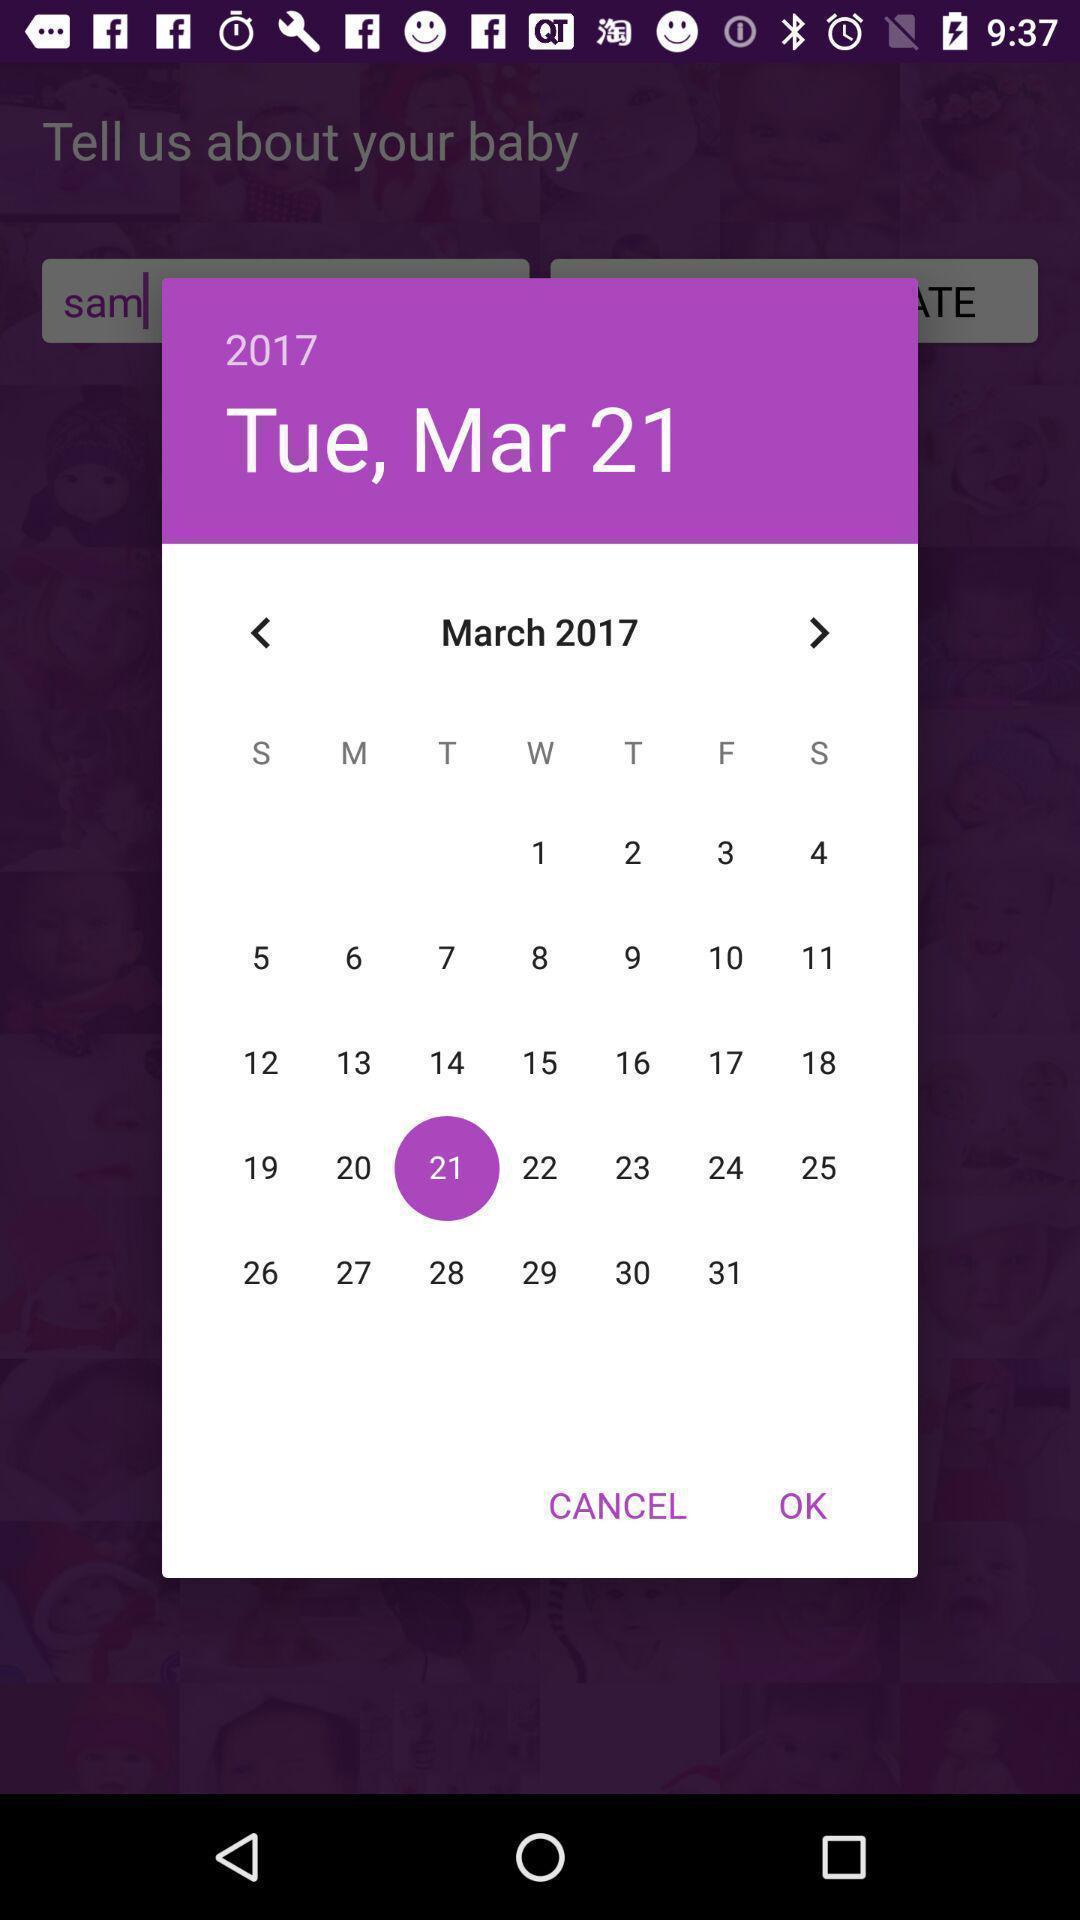Summarize the main components in this picture. Pop-up window showing calendar for a month. 